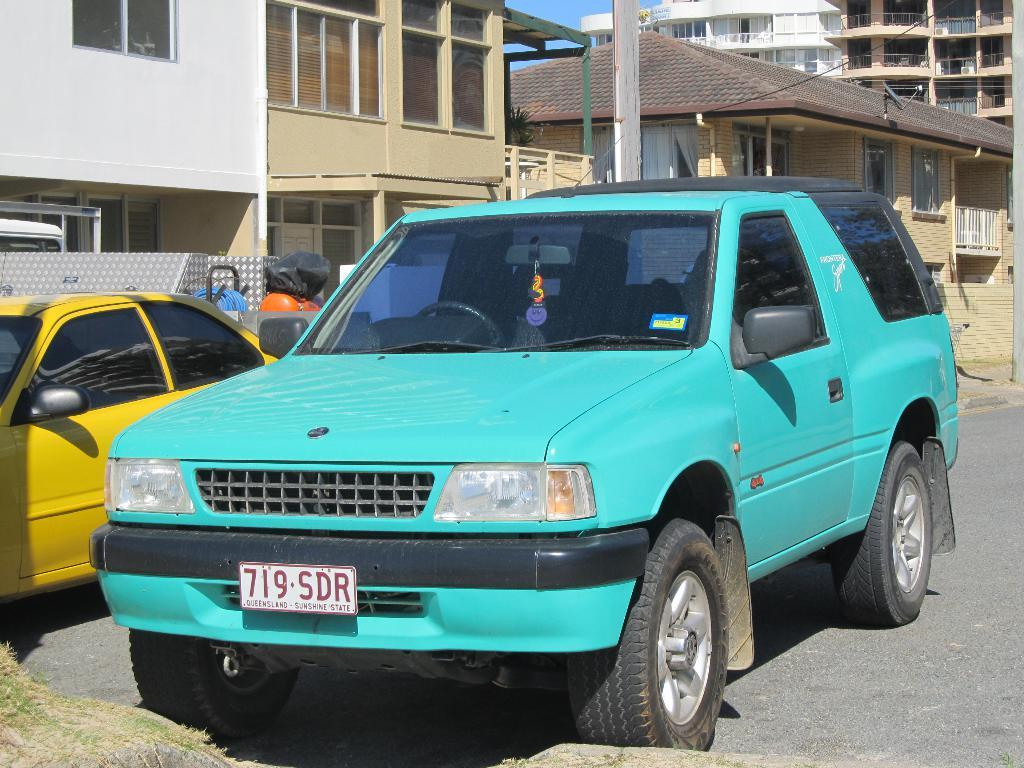<image>
Provide a brief description of the given image. A turquoise colored car is registered in Queensland. 